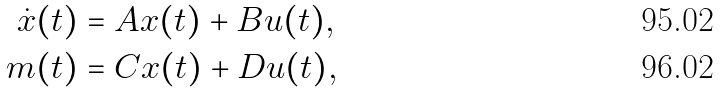Convert formula to latex. <formula><loc_0><loc_0><loc_500><loc_500>\dot { x } ( t ) & = A x ( t ) + B u ( t ) , \\ m ( t ) & = C x ( t ) + D u ( t ) ,</formula> 